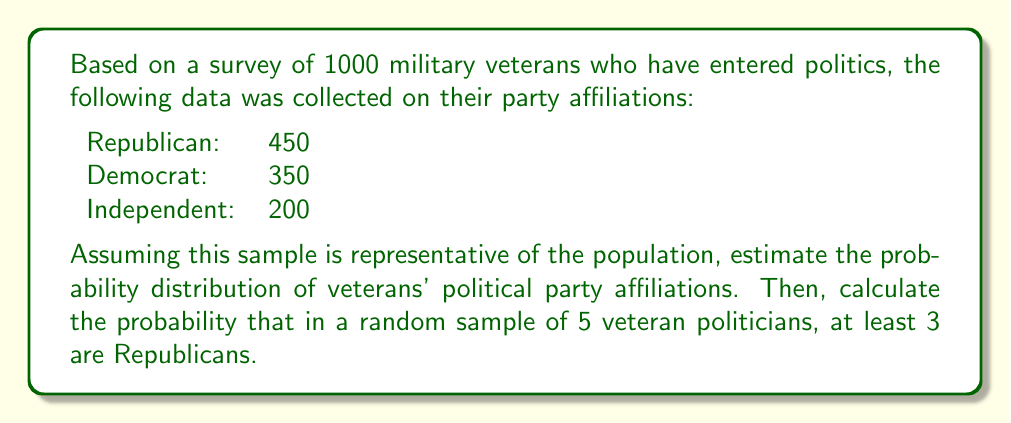What is the answer to this math problem? 1) First, let's calculate the probability distribution based on the given data:

   P(Republican) = 450/1000 = 0.45
   P(Democrat) = 350/1000 = 0.35
   P(Independent) = 200/1000 = 0.20

2) Now, we need to calculate the probability of at least 3 Republicans in a sample of 5. This can be done using the binomial distribution.

3) The probability of exactly k successes in n trials is given by the formula:

   $$P(X = k) = \binom{n}{k} p^k (1-p)^{n-k}$$

   where n is the number of trials, k is the number of successes, and p is the probability of success on each trial.

4) We need to calculate P(X ≥ 3) = P(X = 3) + P(X = 4) + P(X = 5)

5) Let's calculate each term:

   P(X = 3) = $\binom{5}{3} (0.45)^3 (0.55)^2 = 10 * 0.091125 * 0.3025 = 0.2757$

   P(X = 4) = $\binom{5}{4} (0.45)^4 (0.55)^1 = 5 * 0.041006 * 0.55 = 0.1128$

   P(X = 5) = $\binom{5}{5} (0.45)^5 (0.55)^0 = 1 * 0.018455 * 1 = 0.0185$

6) Sum these probabilities:

   P(X ≥ 3) = 0.2757 + 0.1128 + 0.0185 = 0.4070
Answer: Probability distribution: R(0.45), D(0.35), I(0.20). P(at least 3 Republicans in 5) ≈ 0.4070 